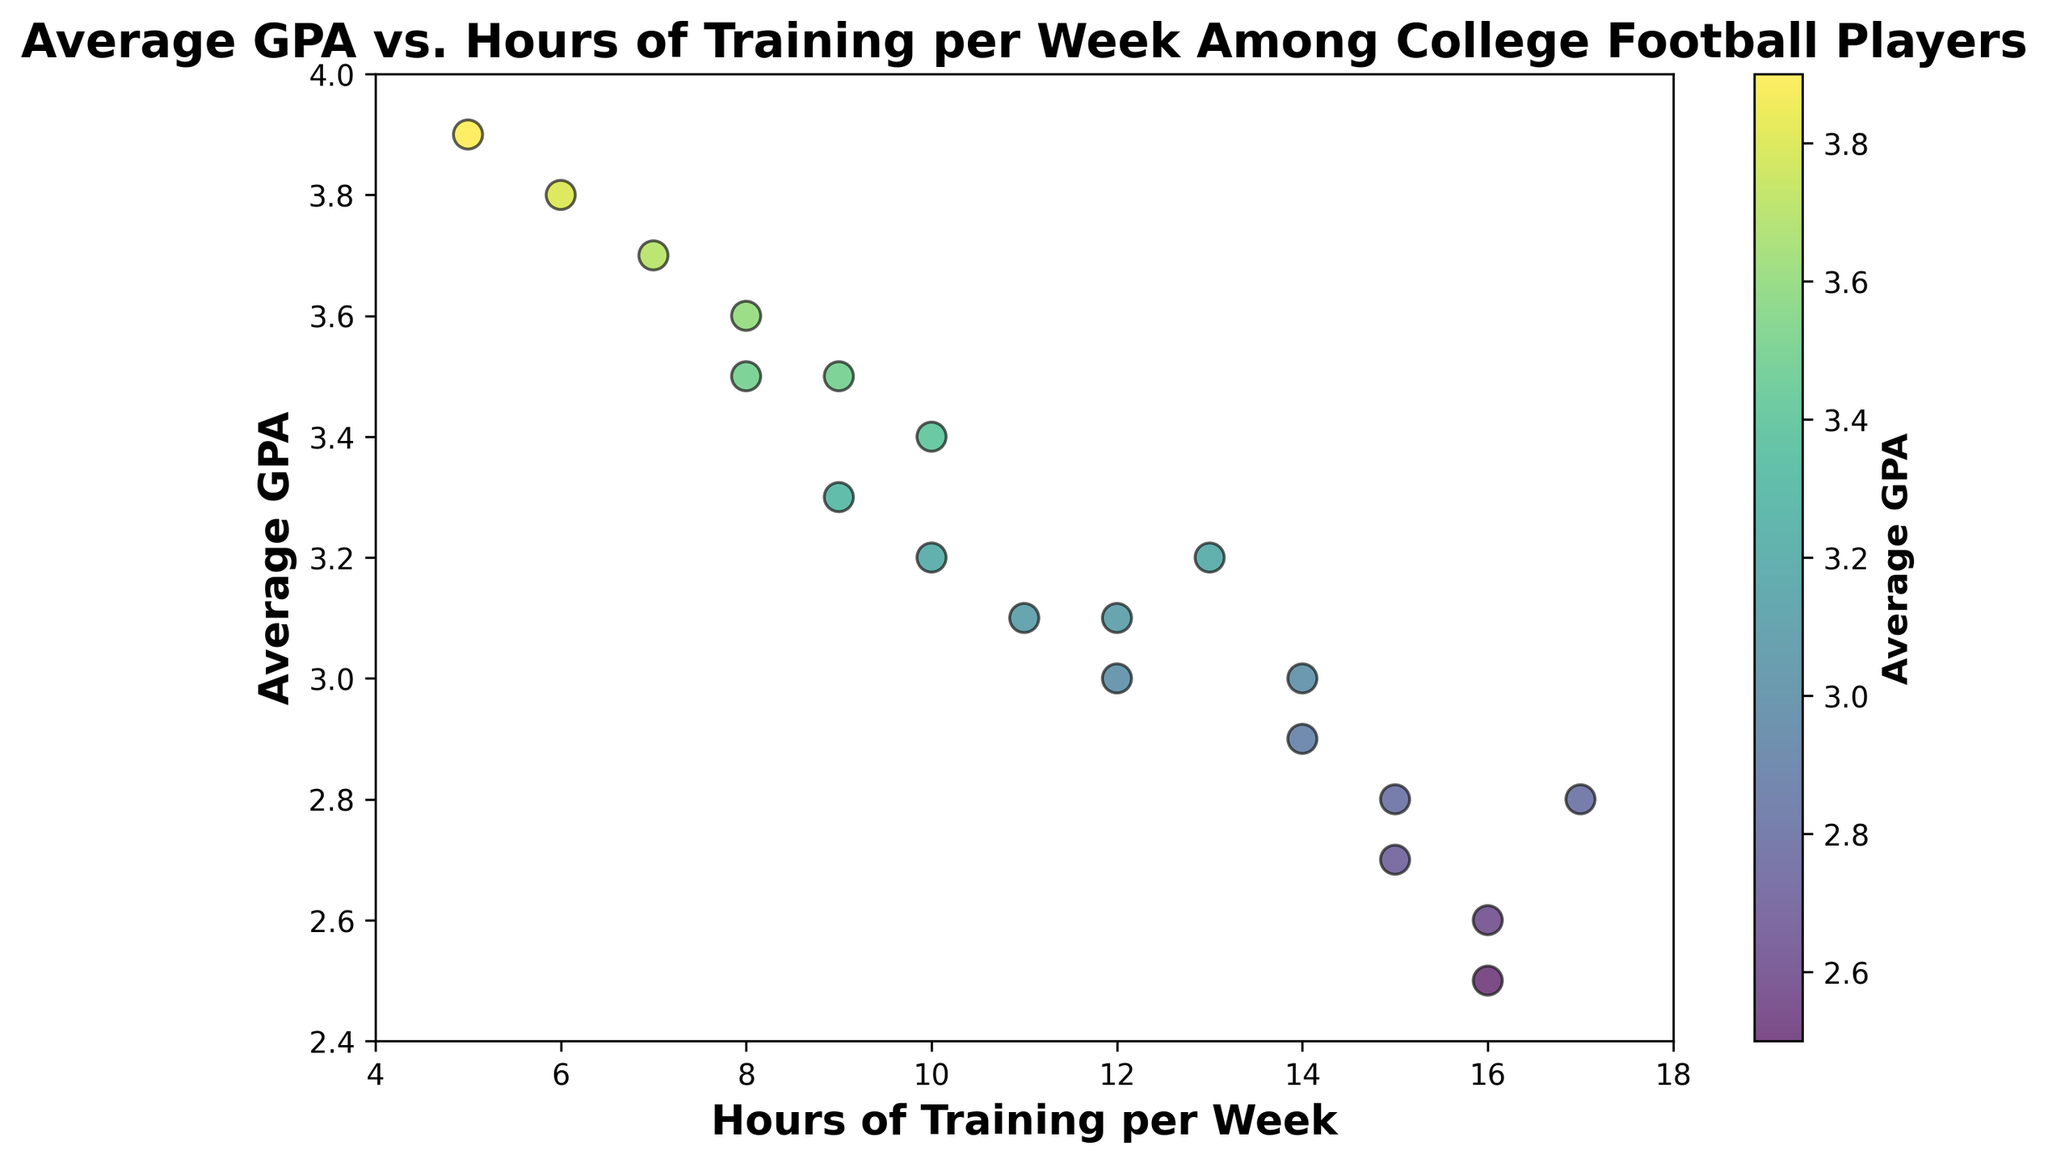What is the range of GPAs among the players? The lowest GPA is 2.5, and the highest GPA is 3.9, so the range is 3.9 - 2.5 = 1.4
Answer: 1.4 Is there a player who trains for 10 hours per week and has a GPA above 3.0? There are two data points for 10 hours of training. One player has a GPA of 3.2 and another has a GPA of 3.4, both of which are above 3.0
Answer: Yes Among the players who train 16 hours per week, which one has the higher GPA? There are two data points for 16 hours of training. One player has a GPA of 2.5 and another has a GPA of 2.6, so the player with a GPA of 2.6 has the higher GPA
Answer: Player with 2.6 GPA Which training hour category has the highest GPA, and what is the GPA? The highest GPA recorded is 3.9, and it corresponds to the player who trains 5 hours per week
Answer: 5 hours, 3.9 GPA What is the median GPA for players training at least 14 hours per week? The GPAs are 2.5, 2.7, 2.8, and 3.0 for players training at least 14 hours per week. The median of these values is the average of 2.8 and 3.0, which is (2.8 + 3.0) / 2 = 2.9
Answer: 2.9 How many players have GPAs below 3.0? Count the number of data points where GPA is below 3.0: 2.8, 2.9, 2.6, 2.7, 2.8, 2.5, 2.8. There are 7 players
Answer: 7 Is there a trend between training hours and GPA? Observing the scatter plot, players with fewer training hours tend to have higher GPAs, and those with more training hours tend to have lower GPAs, indicating a negative correlation
Answer: Negative correlation Which color on the plot represents the highest GPAs? The color bar indicates that higher GPAs are represented by colors transitioning towards light green/yellow
Answer: Light green/yellow Are there any players training for 9 hours per week with a GPA of 3.5 or higher? There are two data points for 9 hours of training, with GPAs of 3.3 and 3.5. Only one player has a GPA of 3.5
Answer: Yes, one player What's the average hours of training per week for players with a GPA of 3.0 or higher? First, find the players with GPA ≥ 3.0: 3.2 (10), 3.5 (8), 3.0 (12), 3.7 (7), 3.1 (11), 3.3 (9), 3.8 (6), 3.4 (10), 3.6 (8), 3.9 (5), 3.0 (14), 3.2 (13), 3.5 (9), 3.1 (12). Sum the hours: 10+8+12+7+11+9+6+10+8+5+14+13+9+12 = 134. There are 14 players, so the average is 134 / 14 = 9.57
Answer: 9.57 